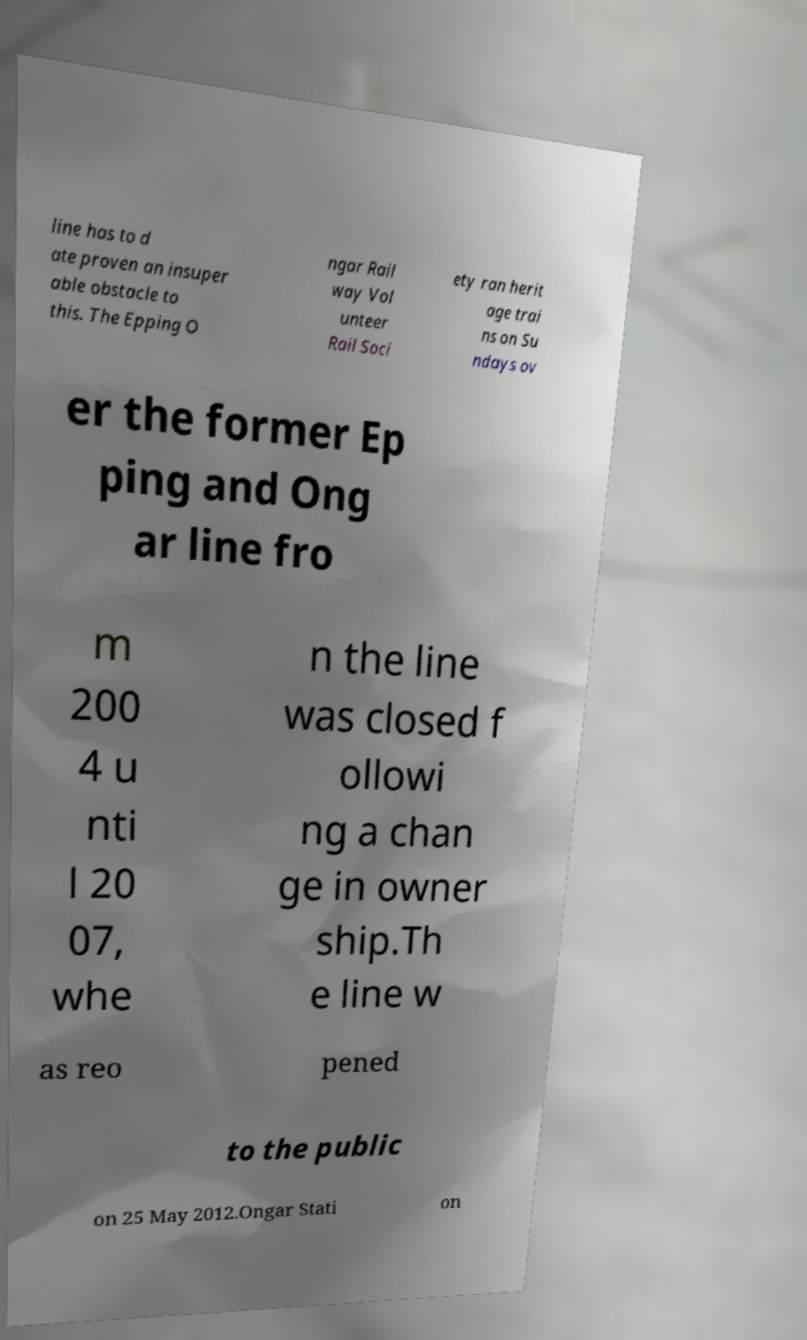Please identify and transcribe the text found in this image. line has to d ate proven an insuper able obstacle to this. The Epping O ngar Rail way Vol unteer Rail Soci ety ran herit age trai ns on Su ndays ov er the former Ep ping and Ong ar line fro m 200 4 u nti l 20 07, whe n the line was closed f ollowi ng a chan ge in owner ship.Th e line w as reo pened to the public on 25 May 2012.Ongar Stati on 